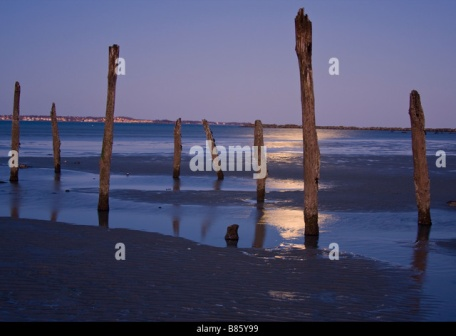Describe a realistic scenario where someone could find themselves at this beach. A realistic scenario could involve a photographer visiting this beach during the golden hours of dusk to capture the beauty of natural light and shadow. They might be drawn to the rustic poles and the tranquil water, finding inspiration in the simple yet striking elements of the scene. Hoping to create a series of evocative images, the photographer carefully chooses angles that highlight the interplay of light and reflections on the wet sand, achieving a series of mesmerizing shots that celebrate the serene beauty of nature. 